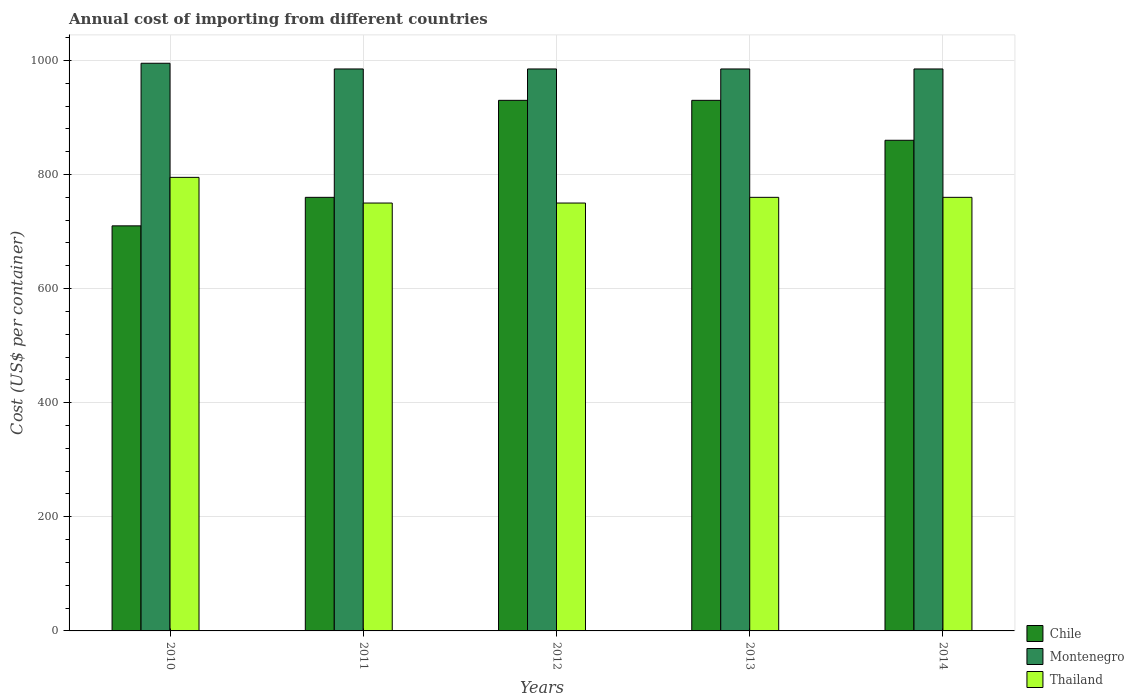How many different coloured bars are there?
Provide a short and direct response. 3. Are the number of bars per tick equal to the number of legend labels?
Offer a terse response. Yes. Are the number of bars on each tick of the X-axis equal?
Provide a succinct answer. Yes. How many bars are there on the 3rd tick from the left?
Offer a very short reply. 3. What is the label of the 5th group of bars from the left?
Your response must be concise. 2014. What is the total annual cost of importing in Montenegro in 2012?
Provide a succinct answer. 985. Across all years, what is the maximum total annual cost of importing in Montenegro?
Offer a terse response. 995. Across all years, what is the minimum total annual cost of importing in Chile?
Keep it short and to the point. 710. What is the total total annual cost of importing in Thailand in the graph?
Provide a succinct answer. 3815. What is the difference between the total annual cost of importing in Thailand in 2010 and that in 2011?
Provide a short and direct response. 45. What is the average total annual cost of importing in Chile per year?
Provide a short and direct response. 838. In the year 2014, what is the difference between the total annual cost of importing in Chile and total annual cost of importing in Thailand?
Your response must be concise. 100. What is the ratio of the total annual cost of importing in Montenegro in 2011 to that in 2014?
Offer a very short reply. 1. What is the difference between the highest and the second highest total annual cost of importing in Montenegro?
Ensure brevity in your answer.  10. What does the 2nd bar from the left in 2010 represents?
Make the answer very short. Montenegro. What does the 2nd bar from the right in 2011 represents?
Your response must be concise. Montenegro. Is it the case that in every year, the sum of the total annual cost of importing in Thailand and total annual cost of importing in Chile is greater than the total annual cost of importing in Montenegro?
Provide a short and direct response. Yes. How many bars are there?
Provide a short and direct response. 15. How many years are there in the graph?
Keep it short and to the point. 5. What is the difference between two consecutive major ticks on the Y-axis?
Make the answer very short. 200. Are the values on the major ticks of Y-axis written in scientific E-notation?
Offer a terse response. No. Does the graph contain grids?
Make the answer very short. Yes. How many legend labels are there?
Offer a very short reply. 3. How are the legend labels stacked?
Provide a succinct answer. Vertical. What is the title of the graph?
Give a very brief answer. Annual cost of importing from different countries. Does "Eritrea" appear as one of the legend labels in the graph?
Offer a very short reply. No. What is the label or title of the Y-axis?
Make the answer very short. Cost (US$ per container). What is the Cost (US$ per container) of Chile in 2010?
Your response must be concise. 710. What is the Cost (US$ per container) of Montenegro in 2010?
Make the answer very short. 995. What is the Cost (US$ per container) in Thailand in 2010?
Offer a terse response. 795. What is the Cost (US$ per container) in Chile in 2011?
Your answer should be very brief. 760. What is the Cost (US$ per container) in Montenegro in 2011?
Your response must be concise. 985. What is the Cost (US$ per container) of Thailand in 2011?
Provide a short and direct response. 750. What is the Cost (US$ per container) of Chile in 2012?
Give a very brief answer. 930. What is the Cost (US$ per container) in Montenegro in 2012?
Offer a terse response. 985. What is the Cost (US$ per container) of Thailand in 2012?
Provide a short and direct response. 750. What is the Cost (US$ per container) in Chile in 2013?
Your answer should be very brief. 930. What is the Cost (US$ per container) in Montenegro in 2013?
Your answer should be compact. 985. What is the Cost (US$ per container) in Thailand in 2013?
Ensure brevity in your answer.  760. What is the Cost (US$ per container) in Chile in 2014?
Your response must be concise. 860. What is the Cost (US$ per container) in Montenegro in 2014?
Make the answer very short. 985. What is the Cost (US$ per container) of Thailand in 2014?
Offer a very short reply. 760. Across all years, what is the maximum Cost (US$ per container) of Chile?
Your answer should be very brief. 930. Across all years, what is the maximum Cost (US$ per container) of Montenegro?
Provide a succinct answer. 995. Across all years, what is the maximum Cost (US$ per container) of Thailand?
Your response must be concise. 795. Across all years, what is the minimum Cost (US$ per container) in Chile?
Ensure brevity in your answer.  710. Across all years, what is the minimum Cost (US$ per container) in Montenegro?
Ensure brevity in your answer.  985. Across all years, what is the minimum Cost (US$ per container) of Thailand?
Offer a very short reply. 750. What is the total Cost (US$ per container) in Chile in the graph?
Provide a short and direct response. 4190. What is the total Cost (US$ per container) of Montenegro in the graph?
Offer a very short reply. 4935. What is the total Cost (US$ per container) of Thailand in the graph?
Ensure brevity in your answer.  3815. What is the difference between the Cost (US$ per container) of Montenegro in 2010 and that in 2011?
Offer a terse response. 10. What is the difference between the Cost (US$ per container) of Chile in 2010 and that in 2012?
Offer a terse response. -220. What is the difference between the Cost (US$ per container) in Montenegro in 2010 and that in 2012?
Your answer should be very brief. 10. What is the difference between the Cost (US$ per container) in Chile in 2010 and that in 2013?
Provide a short and direct response. -220. What is the difference between the Cost (US$ per container) of Montenegro in 2010 and that in 2013?
Give a very brief answer. 10. What is the difference between the Cost (US$ per container) in Chile in 2010 and that in 2014?
Your answer should be compact. -150. What is the difference between the Cost (US$ per container) in Chile in 2011 and that in 2012?
Offer a terse response. -170. What is the difference between the Cost (US$ per container) of Montenegro in 2011 and that in 2012?
Provide a short and direct response. 0. What is the difference between the Cost (US$ per container) of Thailand in 2011 and that in 2012?
Keep it short and to the point. 0. What is the difference between the Cost (US$ per container) in Chile in 2011 and that in 2013?
Provide a succinct answer. -170. What is the difference between the Cost (US$ per container) in Montenegro in 2011 and that in 2013?
Offer a very short reply. 0. What is the difference between the Cost (US$ per container) of Chile in 2011 and that in 2014?
Make the answer very short. -100. What is the difference between the Cost (US$ per container) of Thailand in 2011 and that in 2014?
Make the answer very short. -10. What is the difference between the Cost (US$ per container) in Chile in 2012 and that in 2013?
Make the answer very short. 0. What is the difference between the Cost (US$ per container) in Montenegro in 2012 and that in 2013?
Offer a terse response. 0. What is the difference between the Cost (US$ per container) of Thailand in 2012 and that in 2013?
Keep it short and to the point. -10. What is the difference between the Cost (US$ per container) of Montenegro in 2012 and that in 2014?
Provide a short and direct response. 0. What is the difference between the Cost (US$ per container) in Thailand in 2012 and that in 2014?
Keep it short and to the point. -10. What is the difference between the Cost (US$ per container) in Montenegro in 2013 and that in 2014?
Give a very brief answer. 0. What is the difference between the Cost (US$ per container) in Chile in 2010 and the Cost (US$ per container) in Montenegro in 2011?
Offer a terse response. -275. What is the difference between the Cost (US$ per container) in Montenegro in 2010 and the Cost (US$ per container) in Thailand in 2011?
Give a very brief answer. 245. What is the difference between the Cost (US$ per container) of Chile in 2010 and the Cost (US$ per container) of Montenegro in 2012?
Ensure brevity in your answer.  -275. What is the difference between the Cost (US$ per container) in Montenegro in 2010 and the Cost (US$ per container) in Thailand in 2012?
Your answer should be very brief. 245. What is the difference between the Cost (US$ per container) in Chile in 2010 and the Cost (US$ per container) in Montenegro in 2013?
Offer a very short reply. -275. What is the difference between the Cost (US$ per container) of Montenegro in 2010 and the Cost (US$ per container) of Thailand in 2013?
Provide a short and direct response. 235. What is the difference between the Cost (US$ per container) of Chile in 2010 and the Cost (US$ per container) of Montenegro in 2014?
Your answer should be compact. -275. What is the difference between the Cost (US$ per container) of Montenegro in 2010 and the Cost (US$ per container) of Thailand in 2014?
Offer a very short reply. 235. What is the difference between the Cost (US$ per container) of Chile in 2011 and the Cost (US$ per container) of Montenegro in 2012?
Ensure brevity in your answer.  -225. What is the difference between the Cost (US$ per container) in Chile in 2011 and the Cost (US$ per container) in Thailand in 2012?
Keep it short and to the point. 10. What is the difference between the Cost (US$ per container) in Montenegro in 2011 and the Cost (US$ per container) in Thailand in 2012?
Offer a very short reply. 235. What is the difference between the Cost (US$ per container) of Chile in 2011 and the Cost (US$ per container) of Montenegro in 2013?
Provide a short and direct response. -225. What is the difference between the Cost (US$ per container) of Montenegro in 2011 and the Cost (US$ per container) of Thailand in 2013?
Keep it short and to the point. 225. What is the difference between the Cost (US$ per container) of Chile in 2011 and the Cost (US$ per container) of Montenegro in 2014?
Ensure brevity in your answer.  -225. What is the difference between the Cost (US$ per container) in Chile in 2011 and the Cost (US$ per container) in Thailand in 2014?
Your answer should be very brief. 0. What is the difference between the Cost (US$ per container) of Montenegro in 2011 and the Cost (US$ per container) of Thailand in 2014?
Your answer should be very brief. 225. What is the difference between the Cost (US$ per container) in Chile in 2012 and the Cost (US$ per container) in Montenegro in 2013?
Provide a succinct answer. -55. What is the difference between the Cost (US$ per container) of Chile in 2012 and the Cost (US$ per container) of Thailand in 2013?
Provide a succinct answer. 170. What is the difference between the Cost (US$ per container) of Montenegro in 2012 and the Cost (US$ per container) of Thailand in 2013?
Provide a short and direct response. 225. What is the difference between the Cost (US$ per container) of Chile in 2012 and the Cost (US$ per container) of Montenegro in 2014?
Your answer should be very brief. -55. What is the difference between the Cost (US$ per container) of Chile in 2012 and the Cost (US$ per container) of Thailand in 2014?
Your answer should be very brief. 170. What is the difference between the Cost (US$ per container) of Montenegro in 2012 and the Cost (US$ per container) of Thailand in 2014?
Your answer should be compact. 225. What is the difference between the Cost (US$ per container) of Chile in 2013 and the Cost (US$ per container) of Montenegro in 2014?
Offer a very short reply. -55. What is the difference between the Cost (US$ per container) of Chile in 2013 and the Cost (US$ per container) of Thailand in 2014?
Give a very brief answer. 170. What is the difference between the Cost (US$ per container) of Montenegro in 2013 and the Cost (US$ per container) of Thailand in 2014?
Your answer should be compact. 225. What is the average Cost (US$ per container) of Chile per year?
Provide a succinct answer. 838. What is the average Cost (US$ per container) in Montenegro per year?
Provide a short and direct response. 987. What is the average Cost (US$ per container) in Thailand per year?
Make the answer very short. 763. In the year 2010, what is the difference between the Cost (US$ per container) of Chile and Cost (US$ per container) of Montenegro?
Give a very brief answer. -285. In the year 2010, what is the difference between the Cost (US$ per container) in Chile and Cost (US$ per container) in Thailand?
Offer a terse response. -85. In the year 2011, what is the difference between the Cost (US$ per container) in Chile and Cost (US$ per container) in Montenegro?
Offer a terse response. -225. In the year 2011, what is the difference between the Cost (US$ per container) of Chile and Cost (US$ per container) of Thailand?
Ensure brevity in your answer.  10. In the year 2011, what is the difference between the Cost (US$ per container) in Montenegro and Cost (US$ per container) in Thailand?
Your answer should be compact. 235. In the year 2012, what is the difference between the Cost (US$ per container) of Chile and Cost (US$ per container) of Montenegro?
Provide a succinct answer. -55. In the year 2012, what is the difference between the Cost (US$ per container) of Chile and Cost (US$ per container) of Thailand?
Give a very brief answer. 180. In the year 2012, what is the difference between the Cost (US$ per container) of Montenegro and Cost (US$ per container) of Thailand?
Give a very brief answer. 235. In the year 2013, what is the difference between the Cost (US$ per container) in Chile and Cost (US$ per container) in Montenegro?
Your answer should be very brief. -55. In the year 2013, what is the difference between the Cost (US$ per container) of Chile and Cost (US$ per container) of Thailand?
Provide a short and direct response. 170. In the year 2013, what is the difference between the Cost (US$ per container) of Montenegro and Cost (US$ per container) of Thailand?
Make the answer very short. 225. In the year 2014, what is the difference between the Cost (US$ per container) in Chile and Cost (US$ per container) in Montenegro?
Ensure brevity in your answer.  -125. In the year 2014, what is the difference between the Cost (US$ per container) in Montenegro and Cost (US$ per container) in Thailand?
Your answer should be compact. 225. What is the ratio of the Cost (US$ per container) of Chile in 2010 to that in 2011?
Give a very brief answer. 0.93. What is the ratio of the Cost (US$ per container) of Montenegro in 2010 to that in 2011?
Provide a succinct answer. 1.01. What is the ratio of the Cost (US$ per container) of Thailand in 2010 to that in 2011?
Your answer should be very brief. 1.06. What is the ratio of the Cost (US$ per container) in Chile in 2010 to that in 2012?
Keep it short and to the point. 0.76. What is the ratio of the Cost (US$ per container) of Montenegro in 2010 to that in 2012?
Give a very brief answer. 1.01. What is the ratio of the Cost (US$ per container) of Thailand in 2010 to that in 2012?
Keep it short and to the point. 1.06. What is the ratio of the Cost (US$ per container) in Chile in 2010 to that in 2013?
Your response must be concise. 0.76. What is the ratio of the Cost (US$ per container) of Montenegro in 2010 to that in 2013?
Provide a short and direct response. 1.01. What is the ratio of the Cost (US$ per container) of Thailand in 2010 to that in 2013?
Offer a very short reply. 1.05. What is the ratio of the Cost (US$ per container) of Chile in 2010 to that in 2014?
Give a very brief answer. 0.83. What is the ratio of the Cost (US$ per container) of Montenegro in 2010 to that in 2014?
Provide a short and direct response. 1.01. What is the ratio of the Cost (US$ per container) of Thailand in 2010 to that in 2014?
Give a very brief answer. 1.05. What is the ratio of the Cost (US$ per container) in Chile in 2011 to that in 2012?
Make the answer very short. 0.82. What is the ratio of the Cost (US$ per container) of Chile in 2011 to that in 2013?
Your answer should be compact. 0.82. What is the ratio of the Cost (US$ per container) of Thailand in 2011 to that in 2013?
Your answer should be compact. 0.99. What is the ratio of the Cost (US$ per container) of Chile in 2011 to that in 2014?
Ensure brevity in your answer.  0.88. What is the ratio of the Cost (US$ per container) of Montenegro in 2011 to that in 2014?
Make the answer very short. 1. What is the ratio of the Cost (US$ per container) of Thailand in 2011 to that in 2014?
Your answer should be very brief. 0.99. What is the ratio of the Cost (US$ per container) of Chile in 2012 to that in 2013?
Your answer should be very brief. 1. What is the ratio of the Cost (US$ per container) of Thailand in 2012 to that in 2013?
Offer a terse response. 0.99. What is the ratio of the Cost (US$ per container) in Chile in 2012 to that in 2014?
Make the answer very short. 1.08. What is the ratio of the Cost (US$ per container) of Montenegro in 2012 to that in 2014?
Keep it short and to the point. 1. What is the ratio of the Cost (US$ per container) in Thailand in 2012 to that in 2014?
Ensure brevity in your answer.  0.99. What is the ratio of the Cost (US$ per container) of Chile in 2013 to that in 2014?
Ensure brevity in your answer.  1.08. What is the ratio of the Cost (US$ per container) in Thailand in 2013 to that in 2014?
Your answer should be compact. 1. What is the difference between the highest and the second highest Cost (US$ per container) of Chile?
Offer a very short reply. 0. What is the difference between the highest and the second highest Cost (US$ per container) of Montenegro?
Give a very brief answer. 10. What is the difference between the highest and the second highest Cost (US$ per container) of Thailand?
Ensure brevity in your answer.  35. What is the difference between the highest and the lowest Cost (US$ per container) of Chile?
Offer a very short reply. 220. 